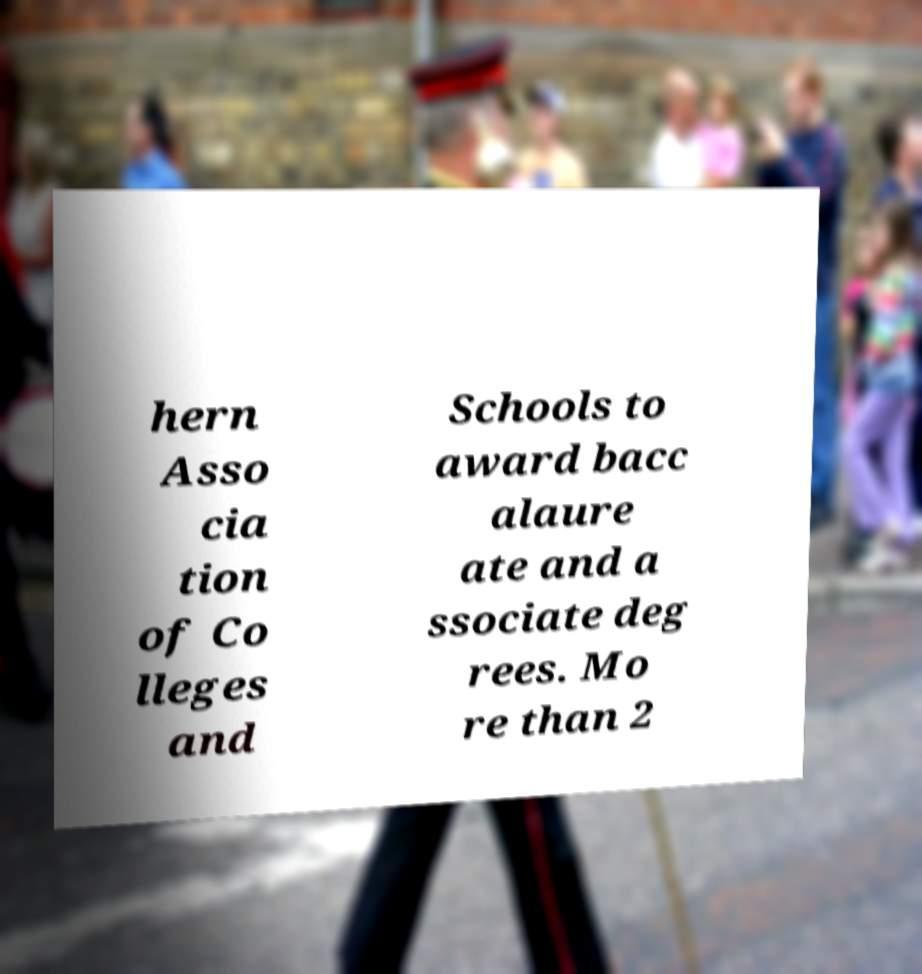Can you accurately transcribe the text from the provided image for me? hern Asso cia tion of Co lleges and Schools to award bacc alaure ate and a ssociate deg rees. Mo re than 2 